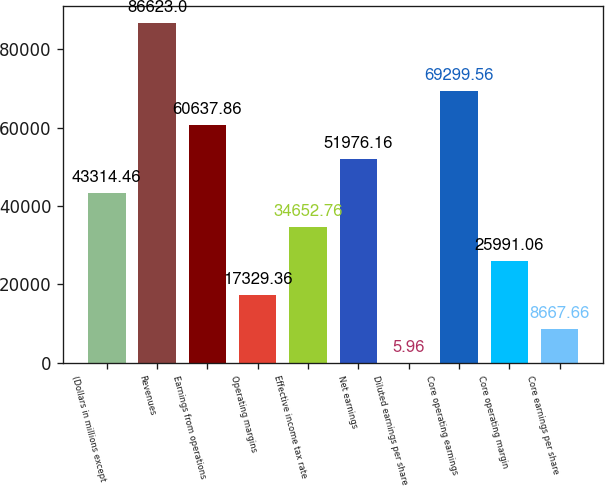Convert chart. <chart><loc_0><loc_0><loc_500><loc_500><bar_chart><fcel>(Dollars in millions except<fcel>Revenues<fcel>Earnings from operations<fcel>Operating margins<fcel>Effective income tax rate<fcel>Net earnings<fcel>Diluted earnings per share<fcel>Core operating earnings<fcel>Core operating margin<fcel>Core earnings per share<nl><fcel>43314.5<fcel>86623<fcel>60637.9<fcel>17329.4<fcel>34652.8<fcel>51976.2<fcel>5.96<fcel>69299.6<fcel>25991.1<fcel>8667.66<nl></chart> 